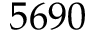Convert formula to latex. <formula><loc_0><loc_0><loc_500><loc_500>5 6 9 0</formula> 